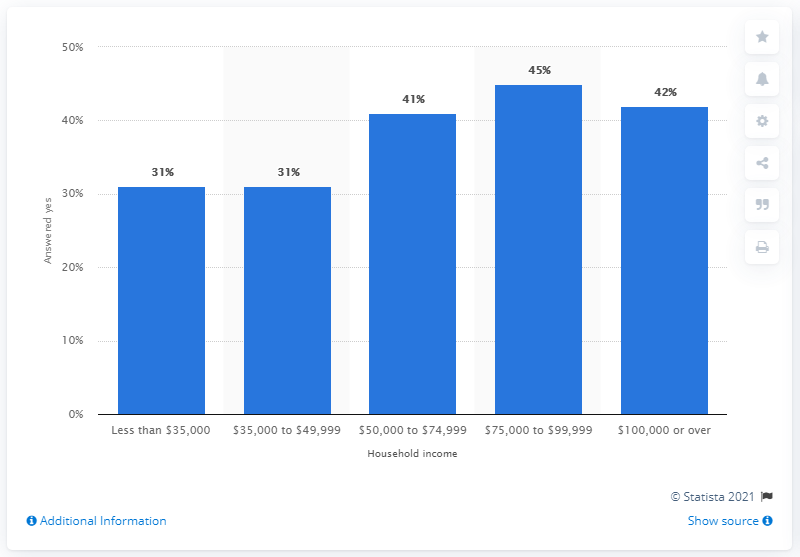What percentage of respondents with a household income between 35,000 and 49,999 U.S. dollars said they follow Major League Baseball?
 31 